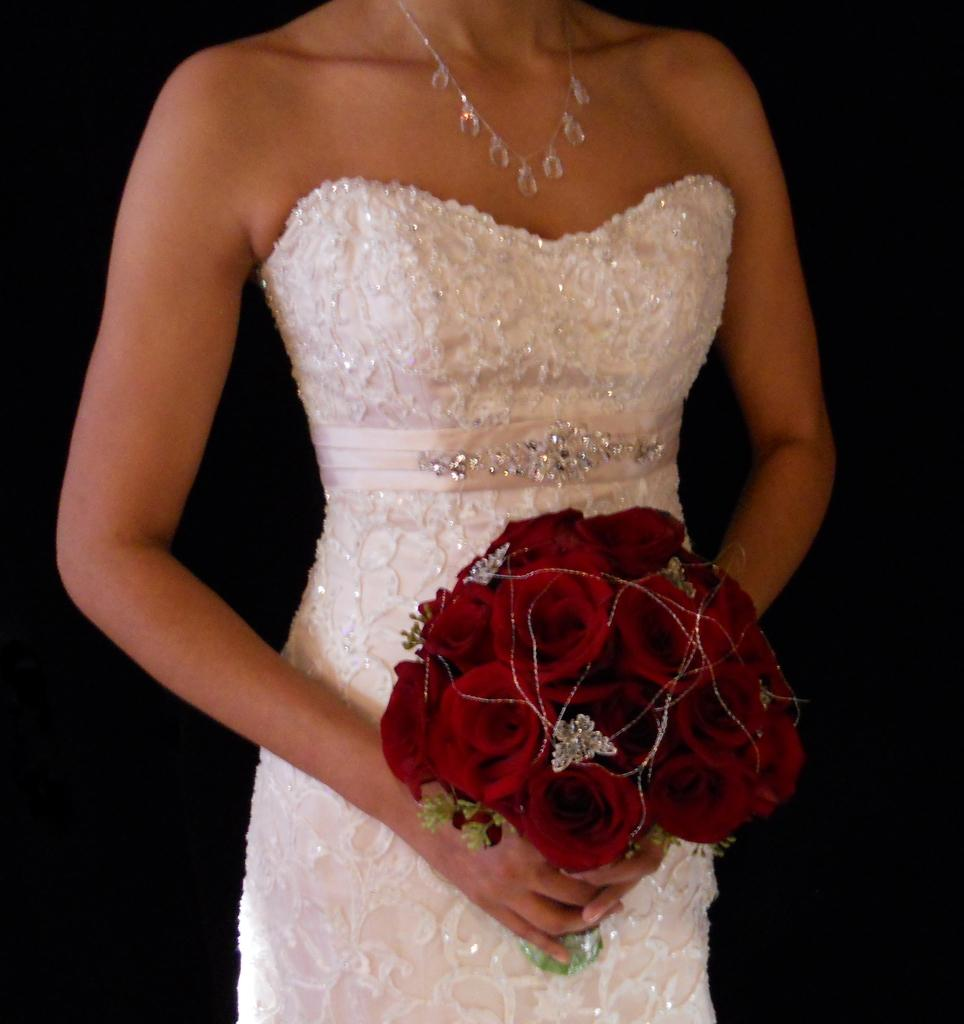What can be seen in the image? There is a person in the image. Can you describe the person's appearance? The person's face is not visible in the image. What is the person wearing? The person is wearing clothes. What is the person holding in the image? The person is holding a bouquet with her hands. What type of flame can be seen coming from the person's hands in the image? There is no flame present in the image; the person is holding a bouquet with her hands. Is there a maid visible in the image? There is no mention of a maid in the provided facts, and no such figure is visible in the image. 